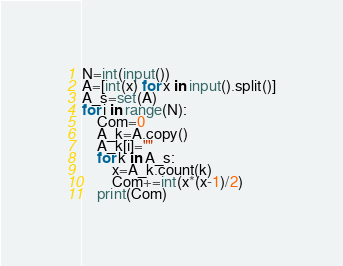Convert code to text. <code><loc_0><loc_0><loc_500><loc_500><_Python_>N=int(input())
A=[int(x) for x in input().split()]
A_s=set(A)
for i in range(N):
    Com=0
    A_k=A.copy()
    A_k[i]=""
    for k in A_s:
        x=A_k.count(k)
        Com+=int(x*(x-1)/2)
    print(Com)</code> 